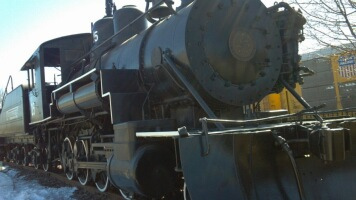<image>Which train has a logo that resembles the American flag? I am not sure which train has a logo that resembles the American flag. Which train has a logo that resembles the American flag? I am not sure which train has a logo that resembles the American flag. 